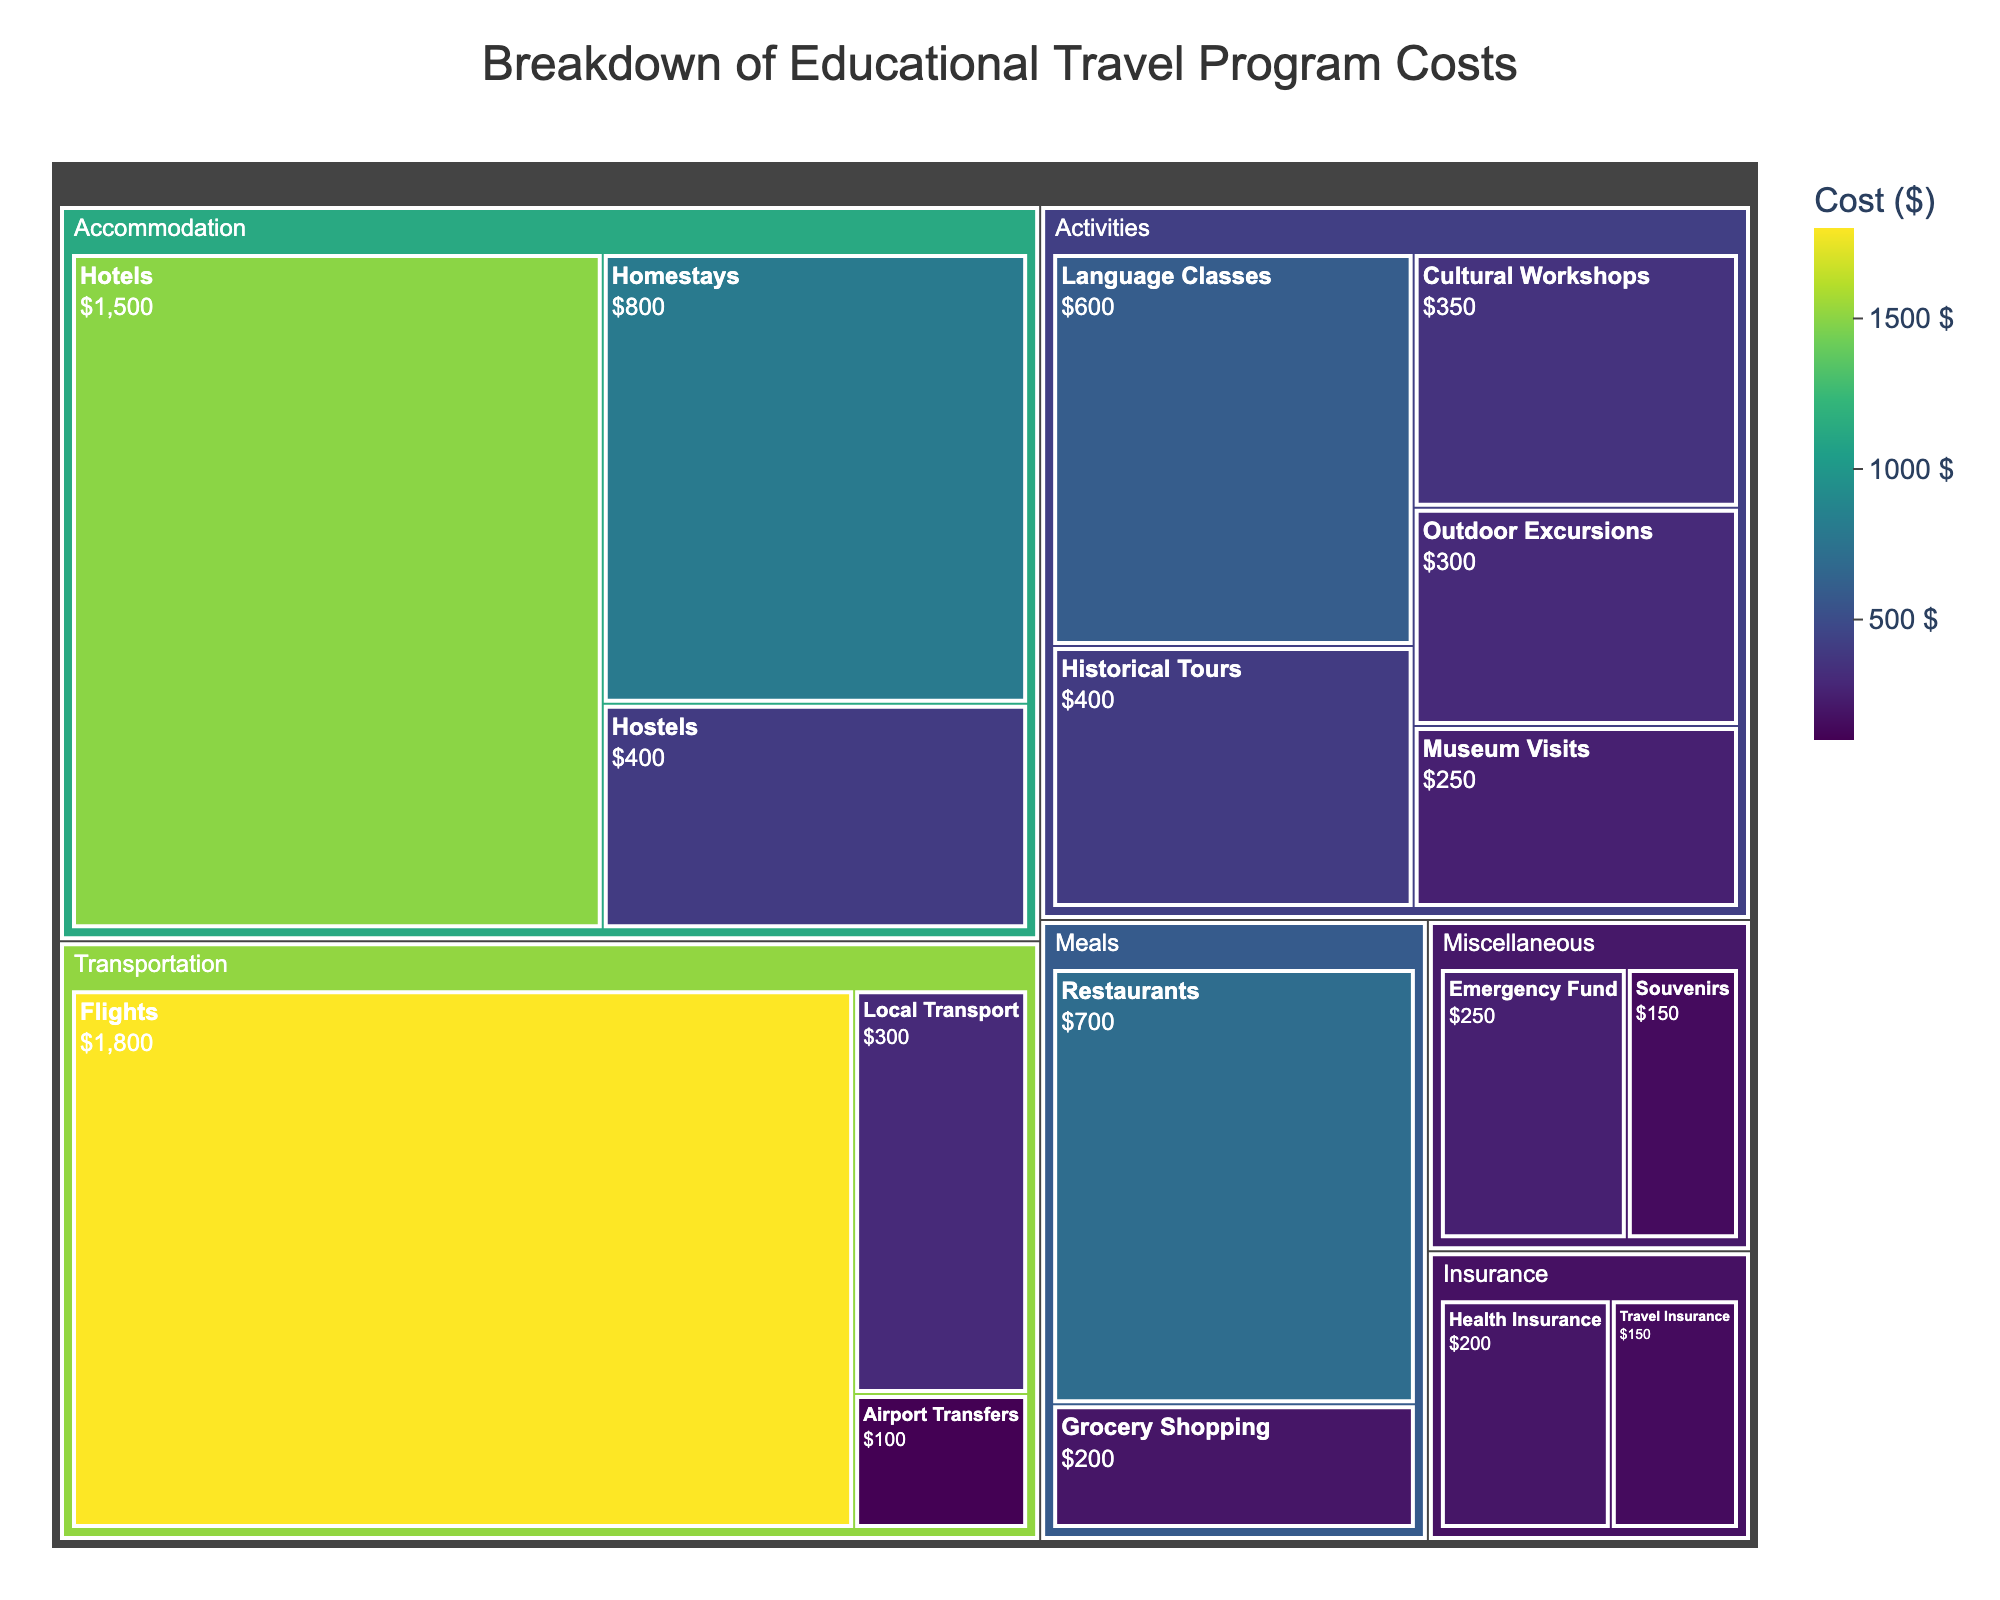What is the title of the treemap? The title of the treemap is written at the top and is usually the most prominent text element.
Answer: Breakdown of Educational Travel Program Costs What category has the highest total cost? By observing the treemap tiles, the size of the tiles is proportional to the cost. The largest category will have the biggest area.
Answer: Transportation Which subcategory in the Activities category has the highest cost? Within the Activities category, the tile with the largest area represents the highest cost.
Answer: Language Classes What is the total cost for all accommodation-related subcategories? Sum the costs of all subcategories under Accommodation: Hotels ($1500) + Homestays ($800) + Hostels ($400).
Answer: $2700 How do the costs of Restaurants and Grocery Shopping compare in the Meals category? Compare the areas of the Restaurants and Grocery Shopping tiles within the Meals category to determine which is larger.
Answer: Restaurants cost more than Grocery Shopping What is the smallest subcategory cost in the treemap? Look for the smallest tile by area in the entire treemap, which represents the lowest cost.
Answer: Travel Insurance How does the cost of Souvenirs compare to the Emergency Fund in the Miscellaneous category? Both Souvenirs and Emergency Fund are subcategories in Miscellaneous. Compare their respective areas.
Answer: Souvenirs cost less than Emergency Fund What is the combined cost of all insurance-related subcategories? Add the costs of Travel Insurance ($150) and Health Insurance ($200) subcategories under Insurance.
Answer: $350 What is the sum of all transportation-related costs? Add together the costs of all subcategories under Transportation: Flights ($1800) + Local Transport ($300) + Airport Transfers ($100).
Answer: $2200 In the Activities category, which subcategory has the lowest cost, and what is it? Look at the Activities category and identify the tile with the smallest area, which represents the lowest cost.
Answer: Outdoor Excursions 